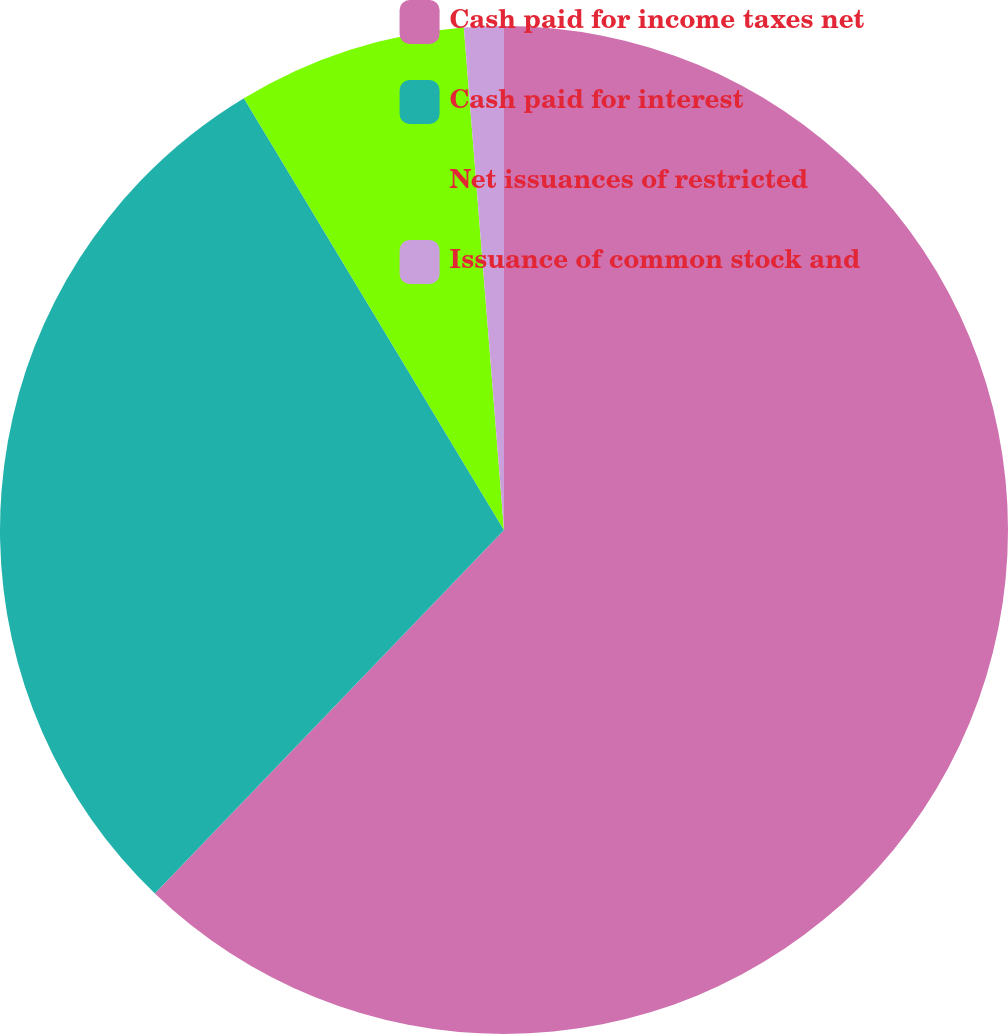Convert chart to OTSL. <chart><loc_0><loc_0><loc_500><loc_500><pie_chart><fcel>Cash paid for income taxes net<fcel>Cash paid for interest<fcel>Net issuances of restricted<fcel>Issuance of common stock and<nl><fcel>62.18%<fcel>29.19%<fcel>7.36%<fcel>1.27%<nl></chart> 